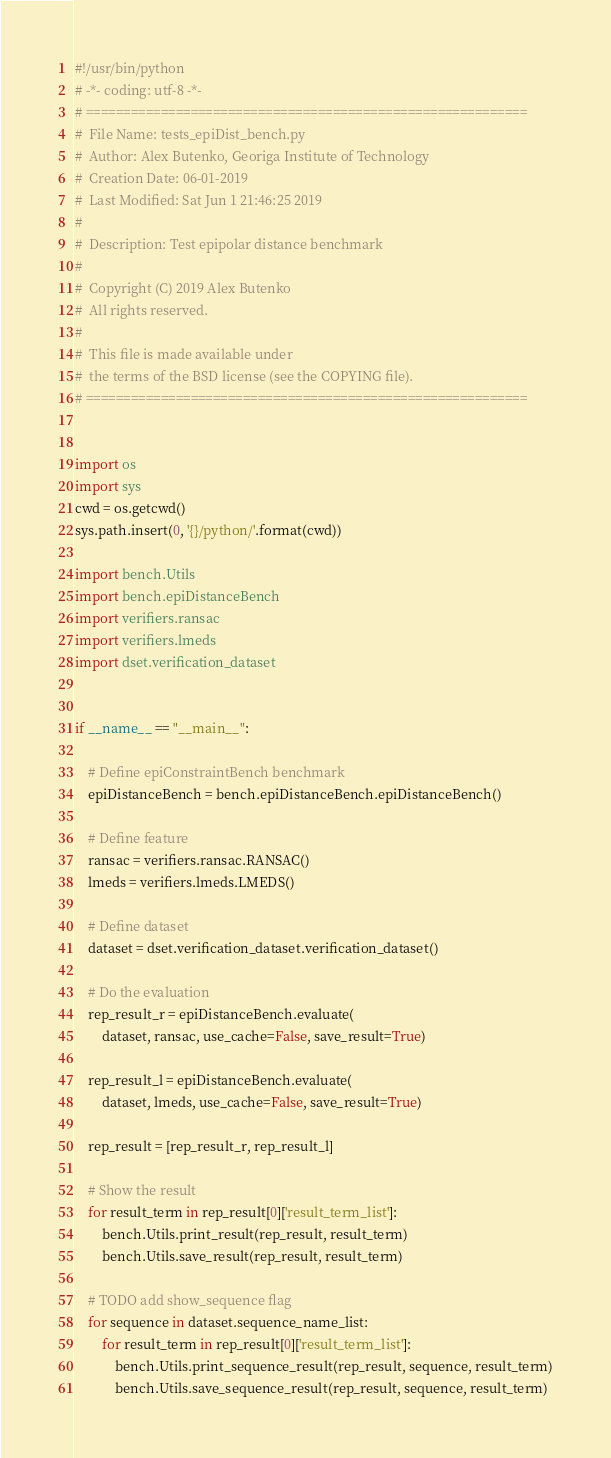Convert code to text. <code><loc_0><loc_0><loc_500><loc_500><_Python_>#!/usr/bin/python
# -*- coding: utf-8 -*-
# ===========================================================
#  File Name: tests_epiDist_bench.py
#  Author: Alex Butenko, Georiga Institute of Technology
#  Creation Date: 06-01-2019
#  Last Modified: Sat Jun 1 21:46:25 2019
#
#  Description: Test epipolar distance benchmark
#
#  Copyright (C) 2019 Alex Butenko
#  All rights reserved.
#
#  This file is made available under
#  the terms of the BSD license (see the COPYING file).
# ===========================================================


import os
import sys
cwd = os.getcwd()
sys.path.insert(0, '{}/python/'.format(cwd))

import bench.Utils
import bench.epiDistanceBench
import verifiers.ransac
import verifiers.lmeds
import dset.verification_dataset


if __name__ == "__main__":

    # Define epiConstraintBench benchmark
    epiDistanceBench = bench.epiDistanceBench.epiDistanceBench()

    # Define feature
    ransac = verifiers.ransac.RANSAC()
    lmeds = verifiers.lmeds.LMEDS()

    # Define dataset
    dataset = dset.verification_dataset.verification_dataset()

    # Do the evaluation
    rep_result_r = epiDistanceBench.evaluate(
        dataset, ransac, use_cache=False, save_result=True)

    rep_result_l = epiDistanceBench.evaluate(
        dataset, lmeds, use_cache=False, save_result=True)

    rep_result = [rep_result_r, rep_result_l]

    # Show the result
    for result_term in rep_result[0]['result_term_list']:
        bench.Utils.print_result(rep_result, result_term)
        bench.Utils.save_result(rep_result, result_term)

    # TODO add show_sequence flag
    for sequence in dataset.sequence_name_list:
        for result_term in rep_result[0]['result_term_list']:
            bench.Utils.print_sequence_result(rep_result, sequence, result_term)
            bench.Utils.save_sequence_result(rep_result, sequence, result_term)
</code> 